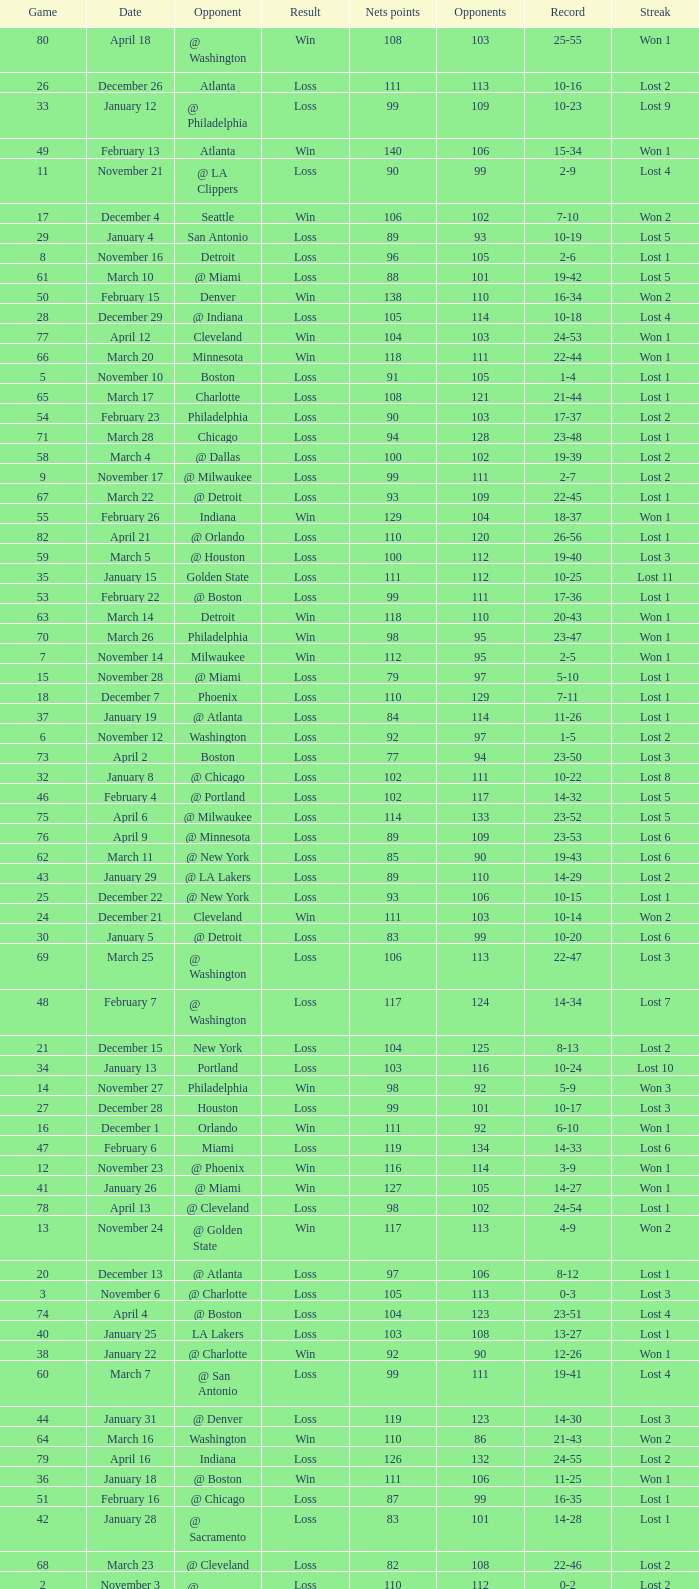In which game did the opponent score more than 103 and the record was 1-3? None. 